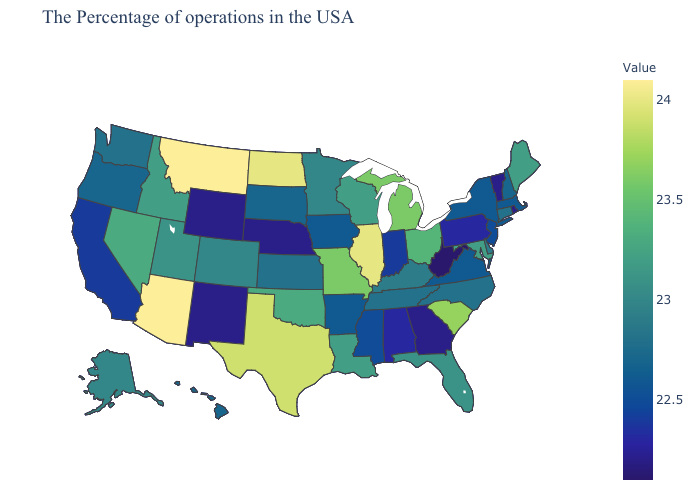Does Idaho have the highest value in the West?
Write a very short answer. No. Among the states that border New Hampshire , does Massachusetts have the lowest value?
Keep it brief. No. Does Arizona have the highest value in the West?
Answer briefly. Yes. Is the legend a continuous bar?
Write a very short answer. Yes. Which states have the lowest value in the USA?
Concise answer only. West Virginia. Among the states that border Arizona , which have the highest value?
Answer briefly. Nevada. Is the legend a continuous bar?
Keep it brief. Yes. 